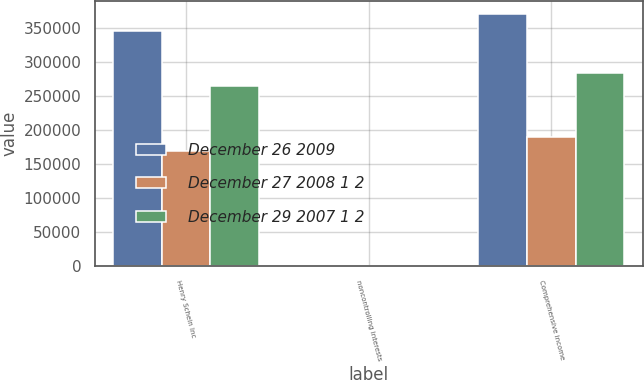Convert chart to OTSL. <chart><loc_0><loc_0><loc_500><loc_500><stacked_bar_chart><ecel><fcel>Henry Schein Inc<fcel>noncontrolling interests<fcel>Comprehensive income<nl><fcel>December 26 2009<fcel>345626<fcel>29<fcel>370171<nl><fcel>December 27 2008 1 2<fcel>168910<fcel>12<fcel>188767<nl><fcel>December 29 2007 1 2<fcel>264639<fcel>92<fcel>282935<nl></chart> 